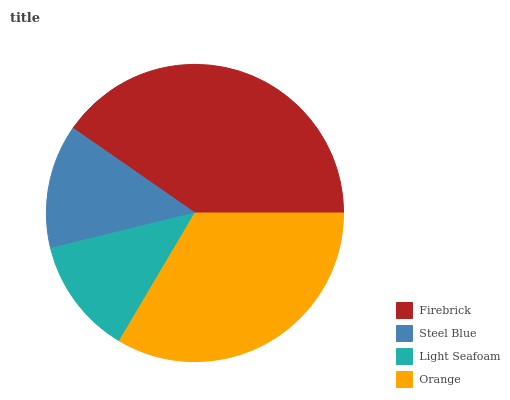Is Light Seafoam the minimum?
Answer yes or no. Yes. Is Firebrick the maximum?
Answer yes or no. Yes. Is Steel Blue the minimum?
Answer yes or no. No. Is Steel Blue the maximum?
Answer yes or no. No. Is Firebrick greater than Steel Blue?
Answer yes or no. Yes. Is Steel Blue less than Firebrick?
Answer yes or no. Yes. Is Steel Blue greater than Firebrick?
Answer yes or no. No. Is Firebrick less than Steel Blue?
Answer yes or no. No. Is Orange the high median?
Answer yes or no. Yes. Is Steel Blue the low median?
Answer yes or no. Yes. Is Firebrick the high median?
Answer yes or no. No. Is Orange the low median?
Answer yes or no. No. 